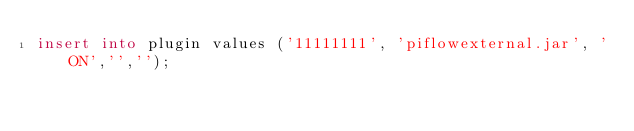Convert code to text. <code><loc_0><loc_0><loc_500><loc_500><_SQL_>insert into plugin values ('11111111', 'piflowexternal.jar', 'ON','','');</code> 